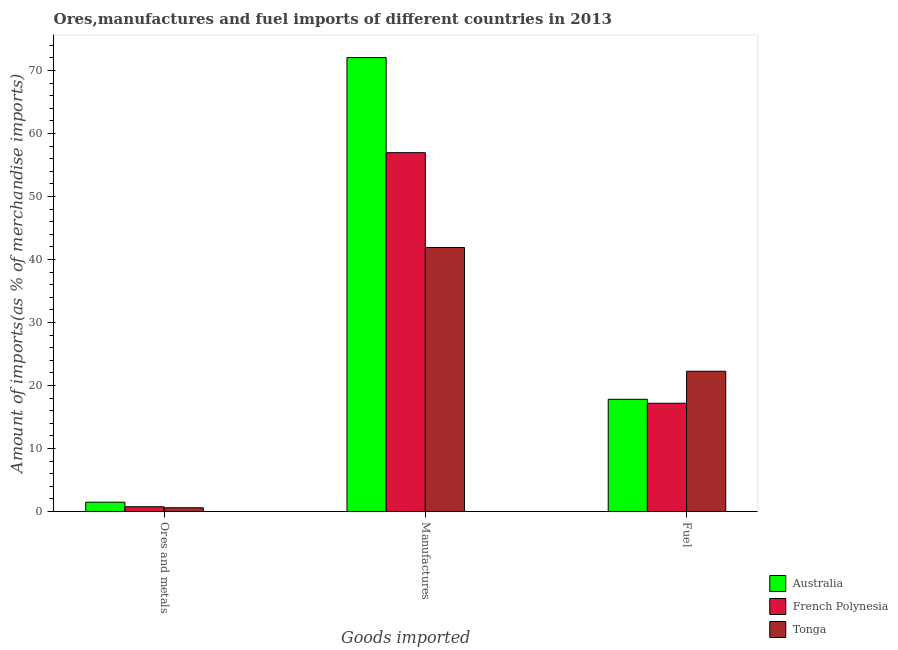How many groups of bars are there?
Offer a terse response. 3. Are the number of bars per tick equal to the number of legend labels?
Ensure brevity in your answer.  Yes. Are the number of bars on each tick of the X-axis equal?
Your answer should be very brief. Yes. How many bars are there on the 3rd tick from the right?
Provide a succinct answer. 3. What is the label of the 3rd group of bars from the left?
Provide a short and direct response. Fuel. What is the percentage of fuel imports in Tonga?
Provide a succinct answer. 22.26. Across all countries, what is the maximum percentage of ores and metals imports?
Provide a succinct answer. 1.48. Across all countries, what is the minimum percentage of fuel imports?
Provide a succinct answer. 17.18. In which country was the percentage of ores and metals imports maximum?
Give a very brief answer. Australia. In which country was the percentage of fuel imports minimum?
Offer a very short reply. French Polynesia. What is the total percentage of fuel imports in the graph?
Make the answer very short. 57.24. What is the difference between the percentage of manufactures imports in French Polynesia and that in Tonga?
Provide a short and direct response. 15.05. What is the difference between the percentage of ores and metals imports in Tonga and the percentage of manufactures imports in French Polynesia?
Offer a very short reply. -56.36. What is the average percentage of manufactures imports per country?
Ensure brevity in your answer.  56.96. What is the difference between the percentage of manufactures imports and percentage of fuel imports in Australia?
Your answer should be compact. 54.24. In how many countries, is the percentage of manufactures imports greater than 52 %?
Provide a succinct answer. 2. What is the ratio of the percentage of fuel imports in Tonga to that in French Polynesia?
Offer a terse response. 1.3. Is the difference between the percentage of fuel imports in Tonga and French Polynesia greater than the difference between the percentage of ores and metals imports in Tonga and French Polynesia?
Ensure brevity in your answer.  Yes. What is the difference between the highest and the second highest percentage of ores and metals imports?
Make the answer very short. 0.72. What is the difference between the highest and the lowest percentage of ores and metals imports?
Provide a succinct answer. 0.89. What does the 3rd bar from the left in Fuel represents?
Provide a short and direct response. Tonga. What does the 1st bar from the right in Ores and metals represents?
Your answer should be very brief. Tonga. Are all the bars in the graph horizontal?
Make the answer very short. No. How many countries are there in the graph?
Your answer should be very brief. 3. Are the values on the major ticks of Y-axis written in scientific E-notation?
Make the answer very short. No. Where does the legend appear in the graph?
Ensure brevity in your answer.  Bottom right. How many legend labels are there?
Your answer should be compact. 3. How are the legend labels stacked?
Offer a very short reply. Vertical. What is the title of the graph?
Your answer should be compact. Ores,manufactures and fuel imports of different countries in 2013. Does "Caribbean small states" appear as one of the legend labels in the graph?
Ensure brevity in your answer.  No. What is the label or title of the X-axis?
Your answer should be compact. Goods imported. What is the label or title of the Y-axis?
Provide a succinct answer. Amount of imports(as % of merchandise imports). What is the Amount of imports(as % of merchandise imports) in Australia in Ores and metals?
Offer a terse response. 1.48. What is the Amount of imports(as % of merchandise imports) of French Polynesia in Ores and metals?
Keep it short and to the point. 0.75. What is the Amount of imports(as % of merchandise imports) of Tonga in Ores and metals?
Offer a terse response. 0.59. What is the Amount of imports(as % of merchandise imports) in Australia in Manufactures?
Offer a very short reply. 72.04. What is the Amount of imports(as % of merchandise imports) in French Polynesia in Manufactures?
Your answer should be very brief. 56.95. What is the Amount of imports(as % of merchandise imports) of Tonga in Manufactures?
Provide a succinct answer. 41.9. What is the Amount of imports(as % of merchandise imports) in Australia in Fuel?
Offer a terse response. 17.8. What is the Amount of imports(as % of merchandise imports) in French Polynesia in Fuel?
Keep it short and to the point. 17.18. What is the Amount of imports(as % of merchandise imports) of Tonga in Fuel?
Give a very brief answer. 22.26. Across all Goods imported, what is the maximum Amount of imports(as % of merchandise imports) in Australia?
Offer a terse response. 72.04. Across all Goods imported, what is the maximum Amount of imports(as % of merchandise imports) of French Polynesia?
Your response must be concise. 56.95. Across all Goods imported, what is the maximum Amount of imports(as % of merchandise imports) of Tonga?
Offer a terse response. 41.9. Across all Goods imported, what is the minimum Amount of imports(as % of merchandise imports) of Australia?
Provide a short and direct response. 1.48. Across all Goods imported, what is the minimum Amount of imports(as % of merchandise imports) of French Polynesia?
Provide a succinct answer. 0.75. Across all Goods imported, what is the minimum Amount of imports(as % of merchandise imports) in Tonga?
Give a very brief answer. 0.59. What is the total Amount of imports(as % of merchandise imports) in Australia in the graph?
Provide a succinct answer. 91.32. What is the total Amount of imports(as % of merchandise imports) in French Polynesia in the graph?
Offer a very short reply. 74.88. What is the total Amount of imports(as % of merchandise imports) of Tonga in the graph?
Your answer should be very brief. 64.75. What is the difference between the Amount of imports(as % of merchandise imports) in Australia in Ores and metals and that in Manufactures?
Your answer should be compact. -70.57. What is the difference between the Amount of imports(as % of merchandise imports) of French Polynesia in Ores and metals and that in Manufactures?
Give a very brief answer. -56.19. What is the difference between the Amount of imports(as % of merchandise imports) in Tonga in Ores and metals and that in Manufactures?
Provide a succinct answer. -41.31. What is the difference between the Amount of imports(as % of merchandise imports) of Australia in Ores and metals and that in Fuel?
Your response must be concise. -16.33. What is the difference between the Amount of imports(as % of merchandise imports) in French Polynesia in Ores and metals and that in Fuel?
Offer a very short reply. -16.43. What is the difference between the Amount of imports(as % of merchandise imports) in Tonga in Ores and metals and that in Fuel?
Your answer should be very brief. -21.67. What is the difference between the Amount of imports(as % of merchandise imports) of Australia in Manufactures and that in Fuel?
Ensure brevity in your answer.  54.24. What is the difference between the Amount of imports(as % of merchandise imports) of French Polynesia in Manufactures and that in Fuel?
Your answer should be very brief. 39.77. What is the difference between the Amount of imports(as % of merchandise imports) of Tonga in Manufactures and that in Fuel?
Your answer should be very brief. 19.64. What is the difference between the Amount of imports(as % of merchandise imports) in Australia in Ores and metals and the Amount of imports(as % of merchandise imports) in French Polynesia in Manufactures?
Give a very brief answer. -55.47. What is the difference between the Amount of imports(as % of merchandise imports) of Australia in Ores and metals and the Amount of imports(as % of merchandise imports) of Tonga in Manufactures?
Provide a succinct answer. -40.42. What is the difference between the Amount of imports(as % of merchandise imports) of French Polynesia in Ores and metals and the Amount of imports(as % of merchandise imports) of Tonga in Manufactures?
Your answer should be very brief. -41.15. What is the difference between the Amount of imports(as % of merchandise imports) of Australia in Ores and metals and the Amount of imports(as % of merchandise imports) of French Polynesia in Fuel?
Ensure brevity in your answer.  -15.7. What is the difference between the Amount of imports(as % of merchandise imports) in Australia in Ores and metals and the Amount of imports(as % of merchandise imports) in Tonga in Fuel?
Offer a terse response. -20.78. What is the difference between the Amount of imports(as % of merchandise imports) of French Polynesia in Ores and metals and the Amount of imports(as % of merchandise imports) of Tonga in Fuel?
Ensure brevity in your answer.  -21.51. What is the difference between the Amount of imports(as % of merchandise imports) in Australia in Manufactures and the Amount of imports(as % of merchandise imports) in French Polynesia in Fuel?
Provide a short and direct response. 54.86. What is the difference between the Amount of imports(as % of merchandise imports) in Australia in Manufactures and the Amount of imports(as % of merchandise imports) in Tonga in Fuel?
Your response must be concise. 49.78. What is the difference between the Amount of imports(as % of merchandise imports) in French Polynesia in Manufactures and the Amount of imports(as % of merchandise imports) in Tonga in Fuel?
Provide a short and direct response. 34.69. What is the average Amount of imports(as % of merchandise imports) of Australia per Goods imported?
Make the answer very short. 30.44. What is the average Amount of imports(as % of merchandise imports) in French Polynesia per Goods imported?
Give a very brief answer. 24.96. What is the average Amount of imports(as % of merchandise imports) in Tonga per Goods imported?
Your answer should be very brief. 21.58. What is the difference between the Amount of imports(as % of merchandise imports) in Australia and Amount of imports(as % of merchandise imports) in French Polynesia in Ores and metals?
Offer a terse response. 0.72. What is the difference between the Amount of imports(as % of merchandise imports) in Australia and Amount of imports(as % of merchandise imports) in Tonga in Ores and metals?
Offer a terse response. 0.89. What is the difference between the Amount of imports(as % of merchandise imports) of French Polynesia and Amount of imports(as % of merchandise imports) of Tonga in Ores and metals?
Your answer should be compact. 0.16. What is the difference between the Amount of imports(as % of merchandise imports) in Australia and Amount of imports(as % of merchandise imports) in French Polynesia in Manufactures?
Your response must be concise. 15.1. What is the difference between the Amount of imports(as % of merchandise imports) in Australia and Amount of imports(as % of merchandise imports) in Tonga in Manufactures?
Provide a succinct answer. 30.14. What is the difference between the Amount of imports(as % of merchandise imports) in French Polynesia and Amount of imports(as % of merchandise imports) in Tonga in Manufactures?
Offer a very short reply. 15.05. What is the difference between the Amount of imports(as % of merchandise imports) of Australia and Amount of imports(as % of merchandise imports) of French Polynesia in Fuel?
Give a very brief answer. 0.62. What is the difference between the Amount of imports(as % of merchandise imports) in Australia and Amount of imports(as % of merchandise imports) in Tonga in Fuel?
Your answer should be compact. -4.46. What is the difference between the Amount of imports(as % of merchandise imports) of French Polynesia and Amount of imports(as % of merchandise imports) of Tonga in Fuel?
Keep it short and to the point. -5.08. What is the ratio of the Amount of imports(as % of merchandise imports) of Australia in Ores and metals to that in Manufactures?
Provide a succinct answer. 0.02. What is the ratio of the Amount of imports(as % of merchandise imports) in French Polynesia in Ores and metals to that in Manufactures?
Your response must be concise. 0.01. What is the ratio of the Amount of imports(as % of merchandise imports) of Tonga in Ores and metals to that in Manufactures?
Keep it short and to the point. 0.01. What is the ratio of the Amount of imports(as % of merchandise imports) of Australia in Ores and metals to that in Fuel?
Offer a terse response. 0.08. What is the ratio of the Amount of imports(as % of merchandise imports) of French Polynesia in Ores and metals to that in Fuel?
Offer a very short reply. 0.04. What is the ratio of the Amount of imports(as % of merchandise imports) of Tonga in Ores and metals to that in Fuel?
Give a very brief answer. 0.03. What is the ratio of the Amount of imports(as % of merchandise imports) in Australia in Manufactures to that in Fuel?
Make the answer very short. 4.05. What is the ratio of the Amount of imports(as % of merchandise imports) in French Polynesia in Manufactures to that in Fuel?
Offer a terse response. 3.31. What is the ratio of the Amount of imports(as % of merchandise imports) of Tonga in Manufactures to that in Fuel?
Your response must be concise. 1.88. What is the difference between the highest and the second highest Amount of imports(as % of merchandise imports) of Australia?
Provide a short and direct response. 54.24. What is the difference between the highest and the second highest Amount of imports(as % of merchandise imports) in French Polynesia?
Keep it short and to the point. 39.77. What is the difference between the highest and the second highest Amount of imports(as % of merchandise imports) in Tonga?
Give a very brief answer. 19.64. What is the difference between the highest and the lowest Amount of imports(as % of merchandise imports) of Australia?
Your answer should be very brief. 70.57. What is the difference between the highest and the lowest Amount of imports(as % of merchandise imports) in French Polynesia?
Provide a succinct answer. 56.19. What is the difference between the highest and the lowest Amount of imports(as % of merchandise imports) in Tonga?
Your response must be concise. 41.31. 